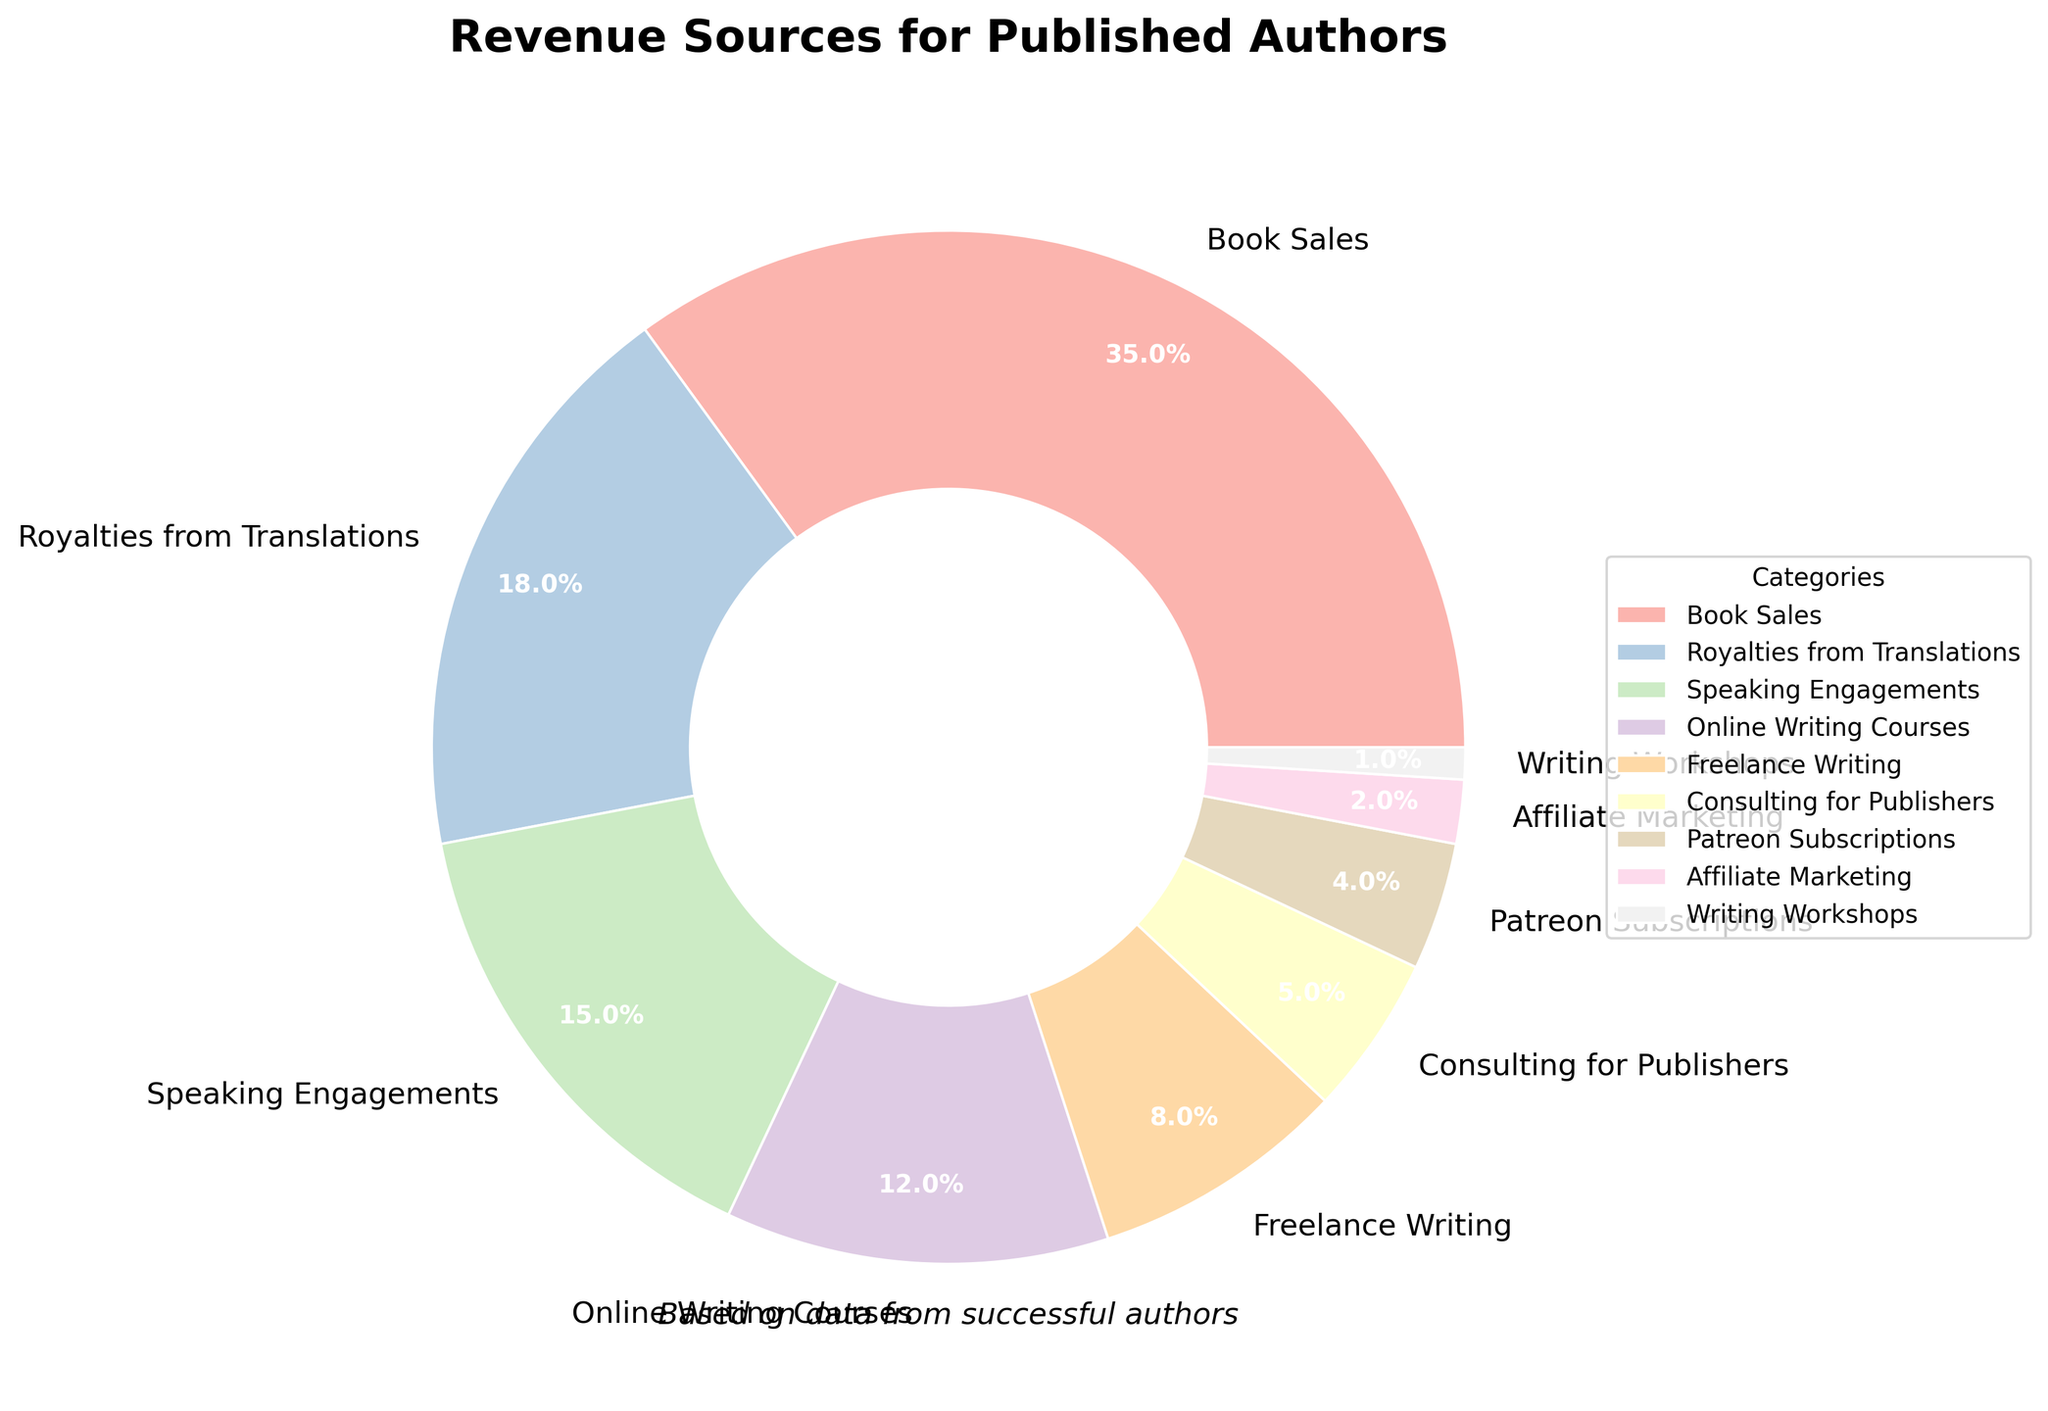What is the largest revenue source for published authors according to the chart? The category "Book Sales" has the largest pie slice with a percentage of 35%, making it the largest revenue source.
Answer: Book Sales Which revenue source is the smallest? The smallest pie slice represents "Writing Workshops" with a percentage of 1%, making it the smallest revenue source.
Answer: Writing Workshops How many categories contribute more than 10% to the total revenue? Categories contributing more than 10% are "Book Sales" (35%), "Royalties from Translations" (18%), "Speaking Engagements" (15%), and "Online Writing Courses" (12%), totaling four categories.
Answer: 4 What's the combined percentage of revenue from "Speaking Engagements" and "Freelance Writing"? The percentage for "Speaking Engagements" is 15%, and "Freelance Writing" is 8%. Adding them together gives 15% + 8% = 23%.
Answer: 23% Which category contributes more to the total revenue: "Royalties from Translations" or "Consulting for Publishers"? "Royalties from Translations" contributes 18%, while "Consulting for Publishers" contributes 5%, making "Royalties from Translations" the larger contributor.
Answer: Royalties from Translations What is the combined percentage of the smallest three categories? The smallest three categories are "Writing Workshops" (1%), "Affiliate Marketing" (2%), and "Patreon Subscriptions" (4%). Adding these gives 1% + 2% + 4% = 7%.
Answer: 7% Which revenue sources contribute less than 10% each? The categories with less than 10% are "Freelance Writing" (8%), "Consulting for Publishers" (5%), "Patreon Subscriptions" (4%), "Affiliate Marketing" (2%), and "Writing Workshops" (1%). There are five such categories.
Answer: Freelance Writing, Consulting for Publishers, Patreon Subscriptions, Affiliate Marketing, Writing Workshops Which revenue categories have percentages that differ by exactly 3%? Comparing the percentages, "Speaking Engagements" (15%) and "Online Writing Courses" (12%) differ by exactly 3%.
Answer: Speaking Engagements and Online Writing Courses 